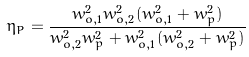Convert formula to latex. <formula><loc_0><loc_0><loc_500><loc_500>\eta _ { P } = \frac { w _ { o , 1 } ^ { 2 } w _ { o , 2 } ^ { 2 } ( w _ { o , 1 } ^ { 2 } + w _ { p } ^ { 2 } ) } { w _ { o , 2 } ^ { 2 } w _ { p } ^ { 2 } + w _ { o , 1 } ^ { 2 } ( w _ { o , 2 } ^ { 2 } + w _ { p } ^ { 2 } ) }</formula> 